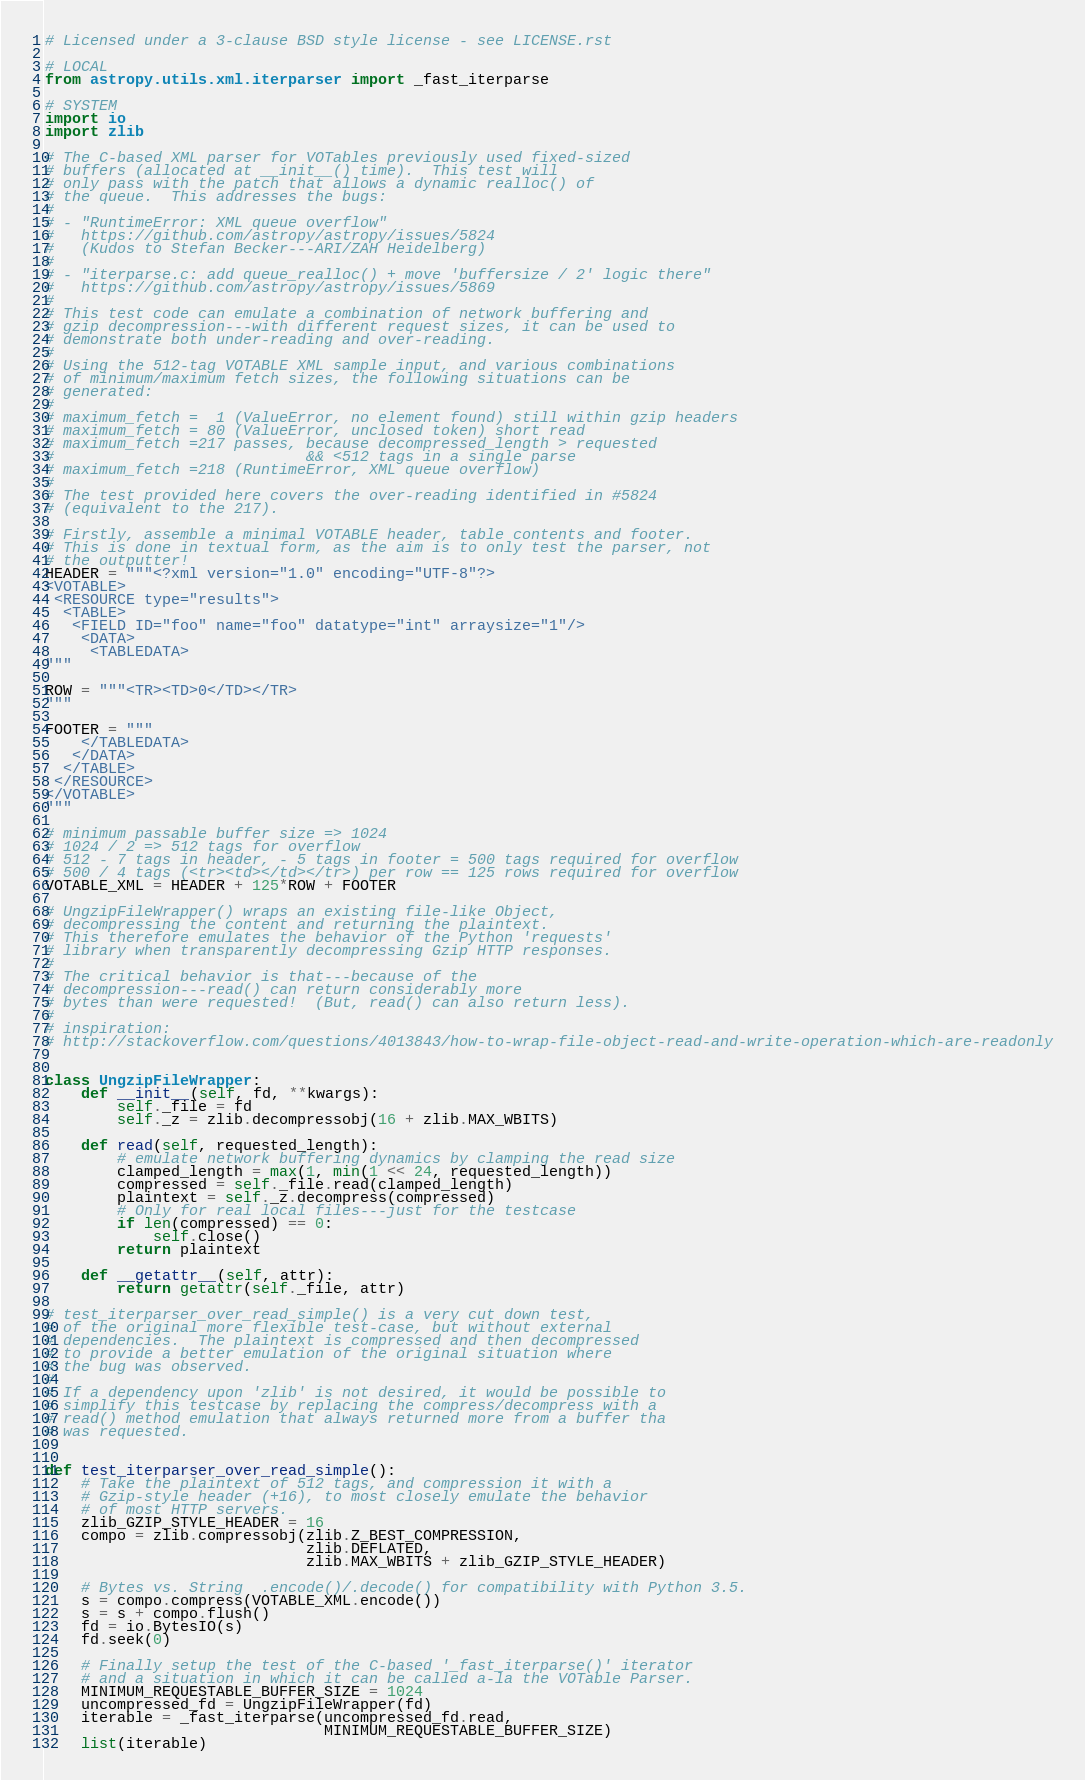Convert code to text. <code><loc_0><loc_0><loc_500><loc_500><_Python_># Licensed under a 3-clause BSD style license - see LICENSE.rst

# LOCAL
from astropy.utils.xml.iterparser import _fast_iterparse

# SYSTEM
import io
import zlib

# The C-based XML parser for VOTables previously used fixed-sized
# buffers (allocated at __init__() time).  This test will
# only pass with the patch that allows a dynamic realloc() of
# the queue.  This addresses the bugs:
#
# - "RuntimeError: XML queue overflow"
#   https://github.com/astropy/astropy/issues/5824
#   (Kudos to Stefan Becker---ARI/ZAH Heidelberg)
#
# - "iterparse.c: add queue_realloc() + move 'buffersize / 2' logic there"
#   https://github.com/astropy/astropy/issues/5869
#
# This test code can emulate a combination of network buffering and
# gzip decompression---with different request sizes, it can be used to
# demonstrate both under-reading and over-reading.
#
# Using the 512-tag VOTABLE XML sample input, and various combinations
# of minimum/maximum fetch sizes, the following situations can be
# generated:
#
# maximum_fetch =  1 (ValueError, no element found) still within gzip headers
# maximum_fetch = 80 (ValueError, unclosed token) short read
# maximum_fetch =217 passes, because decompressed_length > requested
#                            && <512 tags in a single parse
# maximum_fetch =218 (RuntimeError, XML queue overflow)
#
# The test provided here covers the over-reading identified in #5824
# (equivalent to the 217).

# Firstly, assemble a minimal VOTABLE header, table contents and footer.
# This is done in textual form, as the aim is to only test the parser, not
# the outputter!
HEADER = """<?xml version="1.0" encoding="UTF-8"?>
<VOTABLE>
 <RESOURCE type="results">
  <TABLE>
   <FIELD ID="foo" name="foo" datatype="int" arraysize="1"/>
    <DATA>
     <TABLEDATA>
"""

ROW = """<TR><TD>0</TD></TR>
"""

FOOTER = """
    </TABLEDATA>
   </DATA>
  </TABLE>
 </RESOURCE>
</VOTABLE>
"""

# minimum passable buffer size => 1024
# 1024 / 2 => 512 tags for overflow
# 512 - 7 tags in header, - 5 tags in footer = 500 tags required for overflow
# 500 / 4 tags (<tr><td></td></tr>) per row == 125 rows required for overflow
VOTABLE_XML = HEADER + 125*ROW + FOOTER

# UngzipFileWrapper() wraps an existing file-like Object,
# decompressing the content and returning the plaintext.
# This therefore emulates the behavior of the Python 'requests'
# library when transparently decompressing Gzip HTTP responses.
#
# The critical behavior is that---because of the
# decompression---read() can return considerably more
# bytes than were requested!  (But, read() can also return less).
#
# inspiration:
# http://stackoverflow.com/questions/4013843/how-to-wrap-file-object-read-and-write-operation-which-are-readonly


class UngzipFileWrapper:
    def __init__(self, fd, **kwargs):
        self._file = fd
        self._z = zlib.decompressobj(16 + zlib.MAX_WBITS)

    def read(self, requested_length):
        # emulate network buffering dynamics by clamping the read size
        clamped_length = max(1, min(1 << 24, requested_length))
        compressed = self._file.read(clamped_length)
        plaintext = self._z.decompress(compressed)
        # Only for real local files---just for the testcase
        if len(compressed) == 0:
            self.close()
        return plaintext

    def __getattr__(self, attr):
        return getattr(self._file, attr)

# test_iterparser_over_read_simple() is a very cut down test,
# of the original more flexible test-case, but without external
# dependencies.  The plaintext is compressed and then decompressed
# to provide a better emulation of the original situation where
# the bug was observed.
#
# If a dependency upon 'zlib' is not desired, it would be possible to
# simplify this testcase by replacing the compress/decompress with a
# read() method emulation that always returned more from a buffer tha
# was requested.


def test_iterparser_over_read_simple():
    # Take the plaintext of 512 tags, and compression it with a
    # Gzip-style header (+16), to most closely emulate the behavior
    # of most HTTP servers.
    zlib_GZIP_STYLE_HEADER = 16
    compo = zlib.compressobj(zlib.Z_BEST_COMPRESSION,
                             zlib.DEFLATED,
                             zlib.MAX_WBITS + zlib_GZIP_STYLE_HEADER)

    # Bytes vs. String  .encode()/.decode() for compatibility with Python 3.5.
    s = compo.compress(VOTABLE_XML.encode())
    s = s + compo.flush()
    fd = io.BytesIO(s)
    fd.seek(0)

    # Finally setup the test of the C-based '_fast_iterparse()' iterator
    # and a situation in which it can be called a-la the VOTable Parser.
    MINIMUM_REQUESTABLE_BUFFER_SIZE = 1024
    uncompressed_fd = UngzipFileWrapper(fd)
    iterable = _fast_iterparse(uncompressed_fd.read,
                               MINIMUM_REQUESTABLE_BUFFER_SIZE)
    list(iterable)
</code> 